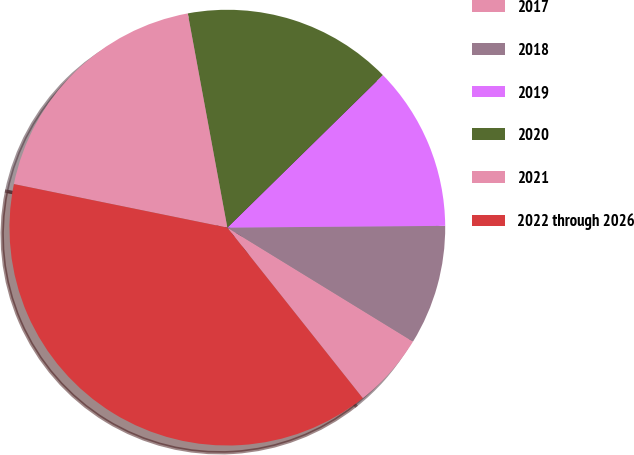Convert chart. <chart><loc_0><loc_0><loc_500><loc_500><pie_chart><fcel>2017<fcel>2018<fcel>2019<fcel>2020<fcel>2021<fcel>2022 through 2026<nl><fcel>5.56%<fcel>8.89%<fcel>12.22%<fcel>15.56%<fcel>18.89%<fcel>38.89%<nl></chart> 